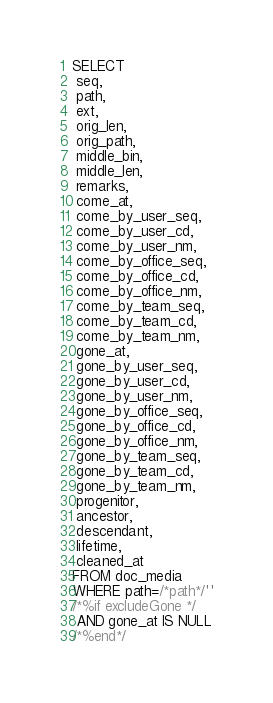<code> <loc_0><loc_0><loc_500><loc_500><_SQL_>SELECT
 seq,
 path,
 ext,
 orig_len,
 orig_path,
 middle_bin,
 middle_len,
 remarks,
 come_at,
 come_by_user_seq,
 come_by_user_cd,
 come_by_user_nm,
 come_by_office_seq,
 come_by_office_cd,
 come_by_office_nm,
 come_by_team_seq,
 come_by_team_cd,
 come_by_team_nm,
 gone_at,
 gone_by_user_seq,
 gone_by_user_cd,
 gone_by_user_nm,
 gone_by_office_seq,
 gone_by_office_cd,
 gone_by_office_nm,
 gone_by_team_seq,
 gone_by_team_cd,
 gone_by_team_nm,
 progenitor,
 ancestor,
 descendant,
 lifetime,
 cleaned_at
FROM doc_media
WHERE path=/*path*/''
/*%if excludeGone */
 AND gone_at IS NULL
/*%end*/
</code> 